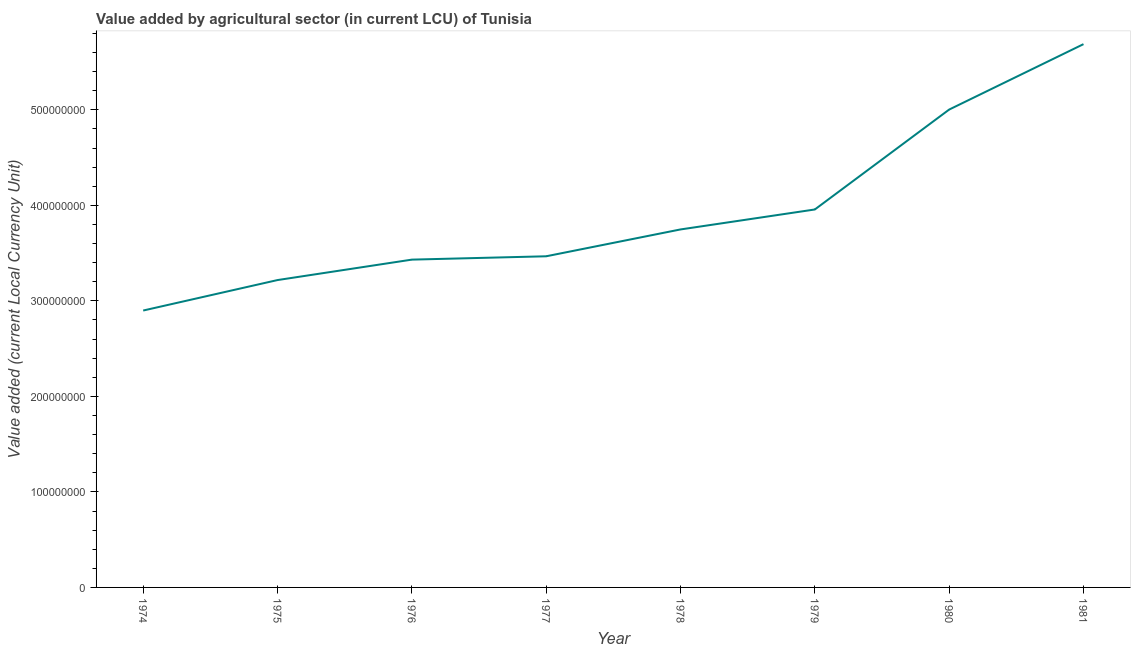What is the value added by agriculture sector in 1978?
Give a very brief answer. 3.75e+08. Across all years, what is the maximum value added by agriculture sector?
Ensure brevity in your answer.  5.69e+08. Across all years, what is the minimum value added by agriculture sector?
Offer a terse response. 2.90e+08. In which year was the value added by agriculture sector minimum?
Provide a short and direct response. 1974. What is the sum of the value added by agriculture sector?
Ensure brevity in your answer.  3.14e+09. What is the difference between the value added by agriculture sector in 1978 and 1979?
Keep it short and to the point. -2.09e+07. What is the average value added by agriculture sector per year?
Give a very brief answer. 3.93e+08. What is the median value added by agriculture sector?
Provide a succinct answer. 3.61e+08. In how many years, is the value added by agriculture sector greater than 340000000 LCU?
Keep it short and to the point. 6. Do a majority of the years between 1974 and 1979 (inclusive) have value added by agriculture sector greater than 460000000 LCU?
Offer a terse response. No. What is the ratio of the value added by agriculture sector in 1974 to that in 1978?
Make the answer very short. 0.77. Is the value added by agriculture sector in 1976 less than that in 1980?
Your answer should be compact. Yes. What is the difference between the highest and the second highest value added by agriculture sector?
Keep it short and to the point. 6.85e+07. What is the difference between the highest and the lowest value added by agriculture sector?
Your response must be concise. 2.79e+08. In how many years, is the value added by agriculture sector greater than the average value added by agriculture sector taken over all years?
Your response must be concise. 3. How many lines are there?
Provide a short and direct response. 1. How many years are there in the graph?
Offer a very short reply. 8. Are the values on the major ticks of Y-axis written in scientific E-notation?
Your answer should be compact. No. Does the graph contain grids?
Make the answer very short. No. What is the title of the graph?
Give a very brief answer. Value added by agricultural sector (in current LCU) of Tunisia. What is the label or title of the Y-axis?
Give a very brief answer. Value added (current Local Currency Unit). What is the Value added (current Local Currency Unit) of 1974?
Your answer should be compact. 2.90e+08. What is the Value added (current Local Currency Unit) in 1975?
Provide a short and direct response. 3.22e+08. What is the Value added (current Local Currency Unit) in 1976?
Provide a short and direct response. 3.43e+08. What is the Value added (current Local Currency Unit) in 1977?
Provide a short and direct response. 3.47e+08. What is the Value added (current Local Currency Unit) in 1978?
Provide a succinct answer. 3.75e+08. What is the Value added (current Local Currency Unit) in 1979?
Offer a terse response. 3.96e+08. What is the Value added (current Local Currency Unit) of 1980?
Provide a short and direct response. 5.00e+08. What is the Value added (current Local Currency Unit) of 1981?
Keep it short and to the point. 5.69e+08. What is the difference between the Value added (current Local Currency Unit) in 1974 and 1975?
Provide a short and direct response. -3.19e+07. What is the difference between the Value added (current Local Currency Unit) in 1974 and 1976?
Your response must be concise. -5.33e+07. What is the difference between the Value added (current Local Currency Unit) in 1974 and 1977?
Make the answer very short. -5.68e+07. What is the difference between the Value added (current Local Currency Unit) in 1974 and 1978?
Ensure brevity in your answer.  -8.49e+07. What is the difference between the Value added (current Local Currency Unit) in 1974 and 1979?
Make the answer very short. -1.06e+08. What is the difference between the Value added (current Local Currency Unit) in 1974 and 1980?
Your response must be concise. -2.10e+08. What is the difference between the Value added (current Local Currency Unit) in 1974 and 1981?
Provide a succinct answer. -2.79e+08. What is the difference between the Value added (current Local Currency Unit) in 1975 and 1976?
Provide a succinct answer. -2.14e+07. What is the difference between the Value added (current Local Currency Unit) in 1975 and 1977?
Your response must be concise. -2.49e+07. What is the difference between the Value added (current Local Currency Unit) in 1975 and 1978?
Make the answer very short. -5.30e+07. What is the difference between the Value added (current Local Currency Unit) in 1975 and 1979?
Offer a very short reply. -7.39e+07. What is the difference between the Value added (current Local Currency Unit) in 1975 and 1980?
Your answer should be very brief. -1.78e+08. What is the difference between the Value added (current Local Currency Unit) in 1975 and 1981?
Ensure brevity in your answer.  -2.47e+08. What is the difference between the Value added (current Local Currency Unit) in 1976 and 1977?
Give a very brief answer. -3.50e+06. What is the difference between the Value added (current Local Currency Unit) in 1976 and 1978?
Offer a terse response. -3.16e+07. What is the difference between the Value added (current Local Currency Unit) in 1976 and 1979?
Provide a short and direct response. -5.25e+07. What is the difference between the Value added (current Local Currency Unit) in 1976 and 1980?
Your answer should be compact. -1.57e+08. What is the difference between the Value added (current Local Currency Unit) in 1976 and 1981?
Make the answer very short. -2.26e+08. What is the difference between the Value added (current Local Currency Unit) in 1977 and 1978?
Provide a short and direct response. -2.81e+07. What is the difference between the Value added (current Local Currency Unit) in 1977 and 1979?
Offer a very short reply. -4.90e+07. What is the difference between the Value added (current Local Currency Unit) in 1977 and 1980?
Ensure brevity in your answer.  -1.54e+08. What is the difference between the Value added (current Local Currency Unit) in 1977 and 1981?
Offer a very short reply. -2.22e+08. What is the difference between the Value added (current Local Currency Unit) in 1978 and 1979?
Give a very brief answer. -2.09e+07. What is the difference between the Value added (current Local Currency Unit) in 1978 and 1980?
Ensure brevity in your answer.  -1.26e+08. What is the difference between the Value added (current Local Currency Unit) in 1978 and 1981?
Your answer should be compact. -1.94e+08. What is the difference between the Value added (current Local Currency Unit) in 1979 and 1980?
Offer a very short reply. -1.05e+08. What is the difference between the Value added (current Local Currency Unit) in 1979 and 1981?
Ensure brevity in your answer.  -1.73e+08. What is the difference between the Value added (current Local Currency Unit) in 1980 and 1981?
Provide a succinct answer. -6.85e+07. What is the ratio of the Value added (current Local Currency Unit) in 1974 to that in 1975?
Provide a short and direct response. 0.9. What is the ratio of the Value added (current Local Currency Unit) in 1974 to that in 1976?
Make the answer very short. 0.84. What is the ratio of the Value added (current Local Currency Unit) in 1974 to that in 1977?
Your answer should be very brief. 0.84. What is the ratio of the Value added (current Local Currency Unit) in 1974 to that in 1978?
Make the answer very short. 0.77. What is the ratio of the Value added (current Local Currency Unit) in 1974 to that in 1979?
Provide a succinct answer. 0.73. What is the ratio of the Value added (current Local Currency Unit) in 1974 to that in 1980?
Give a very brief answer. 0.58. What is the ratio of the Value added (current Local Currency Unit) in 1974 to that in 1981?
Make the answer very short. 0.51. What is the ratio of the Value added (current Local Currency Unit) in 1975 to that in 1976?
Keep it short and to the point. 0.94. What is the ratio of the Value added (current Local Currency Unit) in 1975 to that in 1977?
Provide a succinct answer. 0.93. What is the ratio of the Value added (current Local Currency Unit) in 1975 to that in 1978?
Your answer should be very brief. 0.86. What is the ratio of the Value added (current Local Currency Unit) in 1975 to that in 1979?
Offer a very short reply. 0.81. What is the ratio of the Value added (current Local Currency Unit) in 1975 to that in 1980?
Provide a short and direct response. 0.64. What is the ratio of the Value added (current Local Currency Unit) in 1975 to that in 1981?
Your answer should be compact. 0.57. What is the ratio of the Value added (current Local Currency Unit) in 1976 to that in 1977?
Offer a very short reply. 0.99. What is the ratio of the Value added (current Local Currency Unit) in 1976 to that in 1978?
Your answer should be very brief. 0.92. What is the ratio of the Value added (current Local Currency Unit) in 1976 to that in 1979?
Provide a short and direct response. 0.87. What is the ratio of the Value added (current Local Currency Unit) in 1976 to that in 1980?
Offer a very short reply. 0.69. What is the ratio of the Value added (current Local Currency Unit) in 1976 to that in 1981?
Give a very brief answer. 0.6. What is the ratio of the Value added (current Local Currency Unit) in 1977 to that in 1978?
Your response must be concise. 0.93. What is the ratio of the Value added (current Local Currency Unit) in 1977 to that in 1979?
Keep it short and to the point. 0.88. What is the ratio of the Value added (current Local Currency Unit) in 1977 to that in 1980?
Make the answer very short. 0.69. What is the ratio of the Value added (current Local Currency Unit) in 1977 to that in 1981?
Offer a terse response. 0.61. What is the ratio of the Value added (current Local Currency Unit) in 1978 to that in 1979?
Your response must be concise. 0.95. What is the ratio of the Value added (current Local Currency Unit) in 1978 to that in 1980?
Ensure brevity in your answer.  0.75. What is the ratio of the Value added (current Local Currency Unit) in 1978 to that in 1981?
Give a very brief answer. 0.66. What is the ratio of the Value added (current Local Currency Unit) in 1979 to that in 1980?
Your answer should be compact. 0.79. What is the ratio of the Value added (current Local Currency Unit) in 1979 to that in 1981?
Give a very brief answer. 0.7. What is the ratio of the Value added (current Local Currency Unit) in 1980 to that in 1981?
Offer a very short reply. 0.88. 